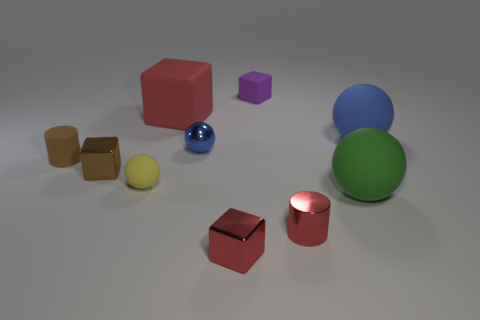Subtract all blue cubes. Subtract all cyan cylinders. How many cubes are left? 4 Subtract all cylinders. How many objects are left? 8 Add 9 red metallic cylinders. How many red metallic cylinders are left? 10 Add 5 blue metallic spheres. How many blue metallic spheres exist? 6 Subtract 0 brown balls. How many objects are left? 10 Subtract all big blocks. Subtract all brown cylinders. How many objects are left? 8 